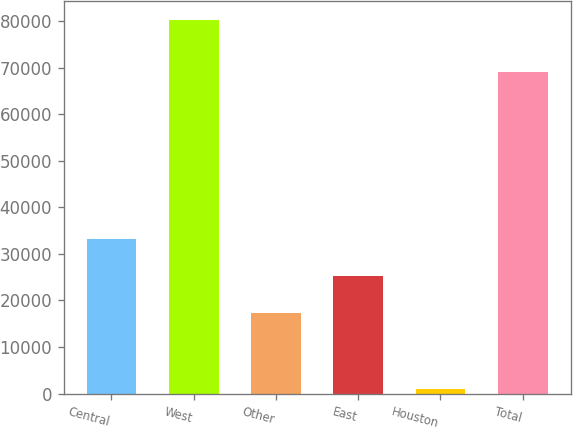<chart> <loc_0><loc_0><loc_500><loc_500><bar_chart><fcel>Central<fcel>West<fcel>Other<fcel>East<fcel>Houston<fcel>Total<nl><fcel>33218.2<fcel>80207<fcel>17375<fcel>25296.6<fcel>991<fcel>69077<nl></chart> 